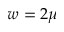<formula> <loc_0><loc_0><loc_500><loc_500>w = 2 \mu</formula> 